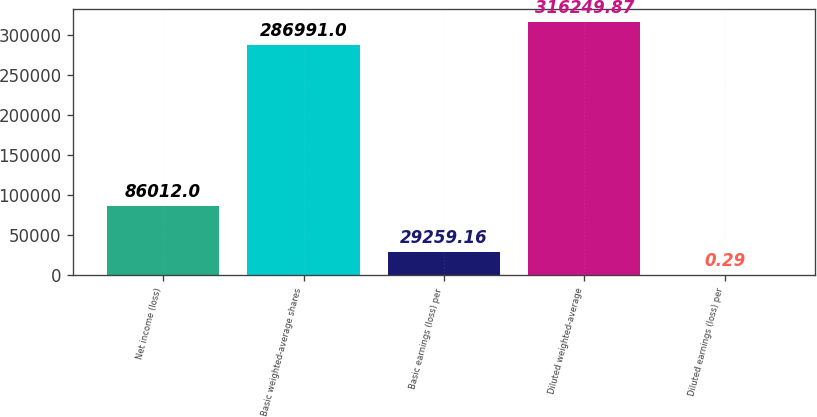Convert chart to OTSL. <chart><loc_0><loc_0><loc_500><loc_500><bar_chart><fcel>Net income (loss)<fcel>Basic weighted-average shares<fcel>Basic earnings (loss) per<fcel>Diluted weighted-average<fcel>Diluted earnings (loss) per<nl><fcel>86012<fcel>286991<fcel>29259.2<fcel>316250<fcel>0.29<nl></chart> 